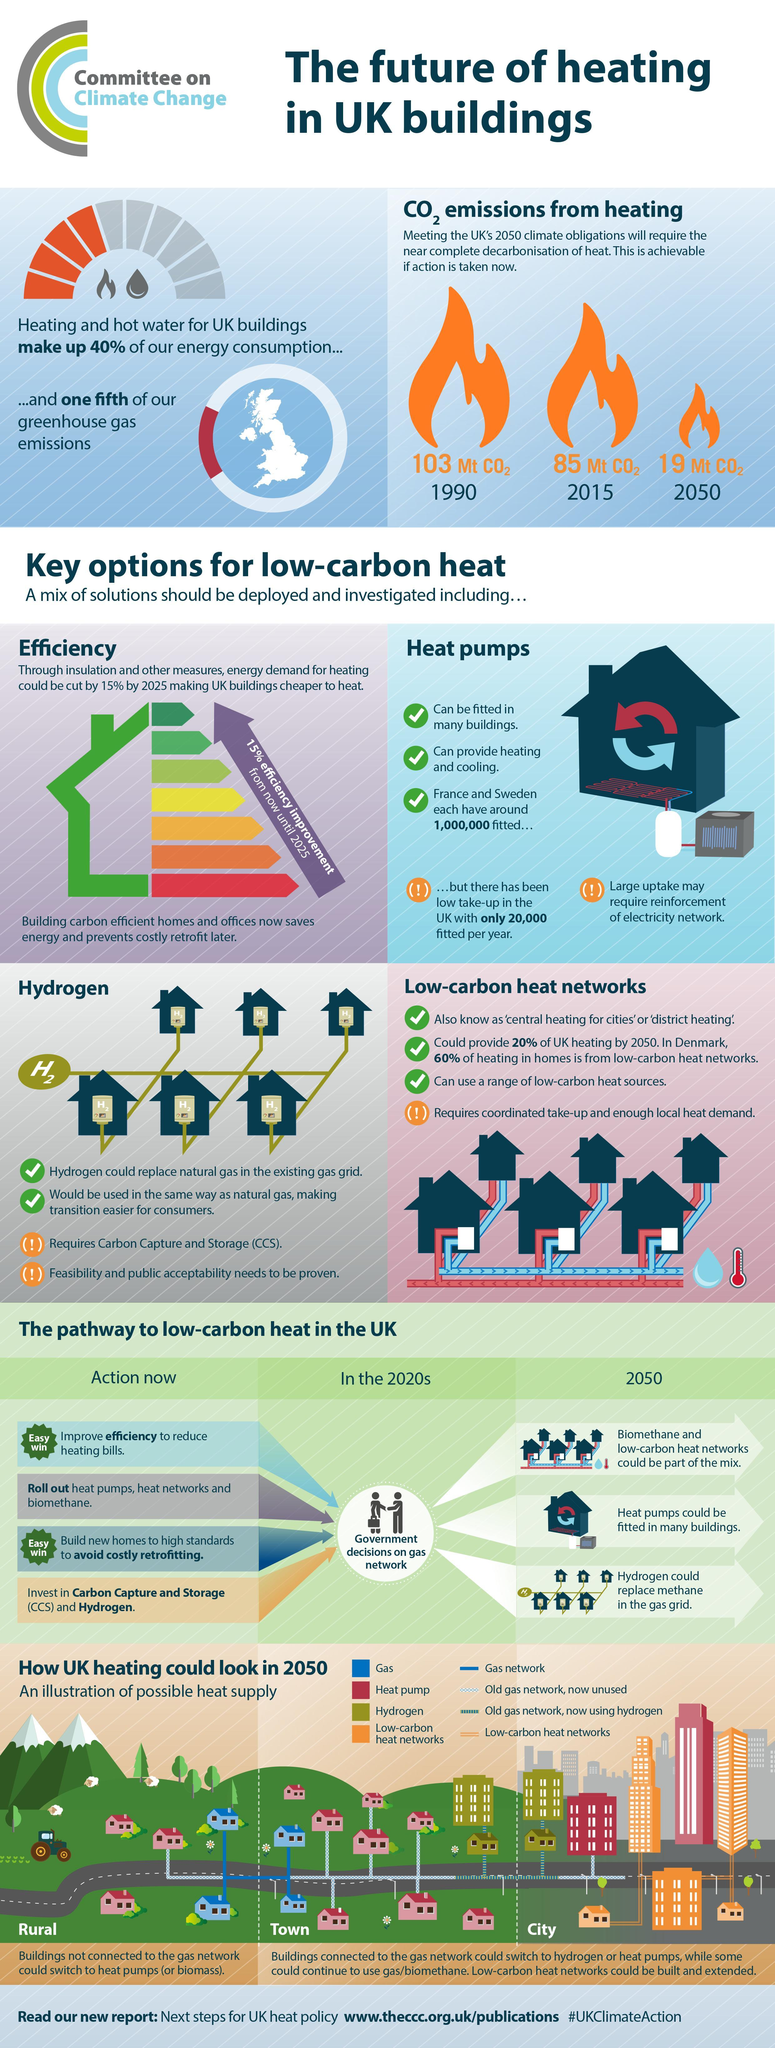How many heat pumps have been fitted in France?
Answer the question with a short phrase. around 1,000,000 What percentage of greenhouse gas emissions in UK are contributed by heating and hot water? 20% 